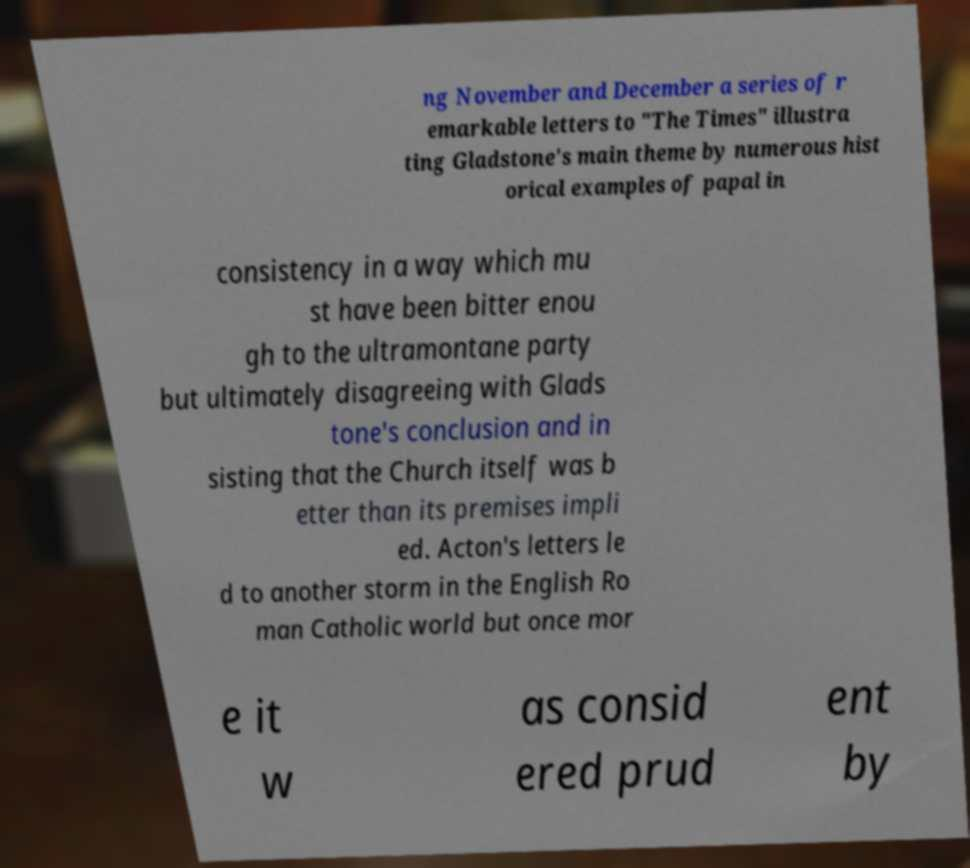Could you extract and type out the text from this image? ng November and December a series of r emarkable letters to "The Times" illustra ting Gladstone's main theme by numerous hist orical examples of papal in consistency in a way which mu st have been bitter enou gh to the ultramontane party but ultimately disagreeing with Glads tone's conclusion and in sisting that the Church itself was b etter than its premises impli ed. Acton's letters le d to another storm in the English Ro man Catholic world but once mor e it w as consid ered prud ent by 